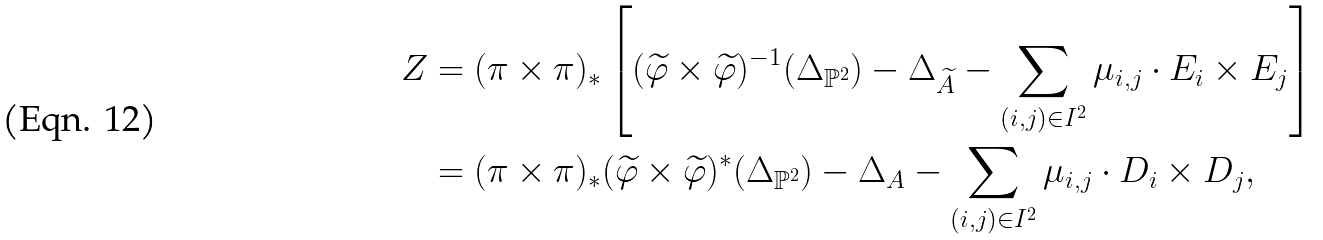Convert formula to latex. <formula><loc_0><loc_0><loc_500><loc_500>Z & = ( \pi \times \pi ) _ { * } \left [ ( \widetilde { \varphi } \times \widetilde { \varphi } ) ^ { - 1 } ( \Delta _ { \mathbb { P } ^ { 2 } } ) - \Delta _ { \widetilde { A } } - \sum _ { ( i , j ) \in I ^ { 2 } } \mu _ { i , j } \cdot E _ { i } \times E _ { j } \right ] \\ & = ( \pi \times \pi ) _ { * } ( \widetilde { \varphi } \times \widetilde { \varphi } ) ^ { * } ( \Delta _ { \mathbb { P } ^ { 2 } } ) - \Delta _ { A } - \sum _ { ( i , j ) \in I ^ { 2 } } \mu _ { i , j } \cdot D _ { i } \times D _ { j } ,</formula> 